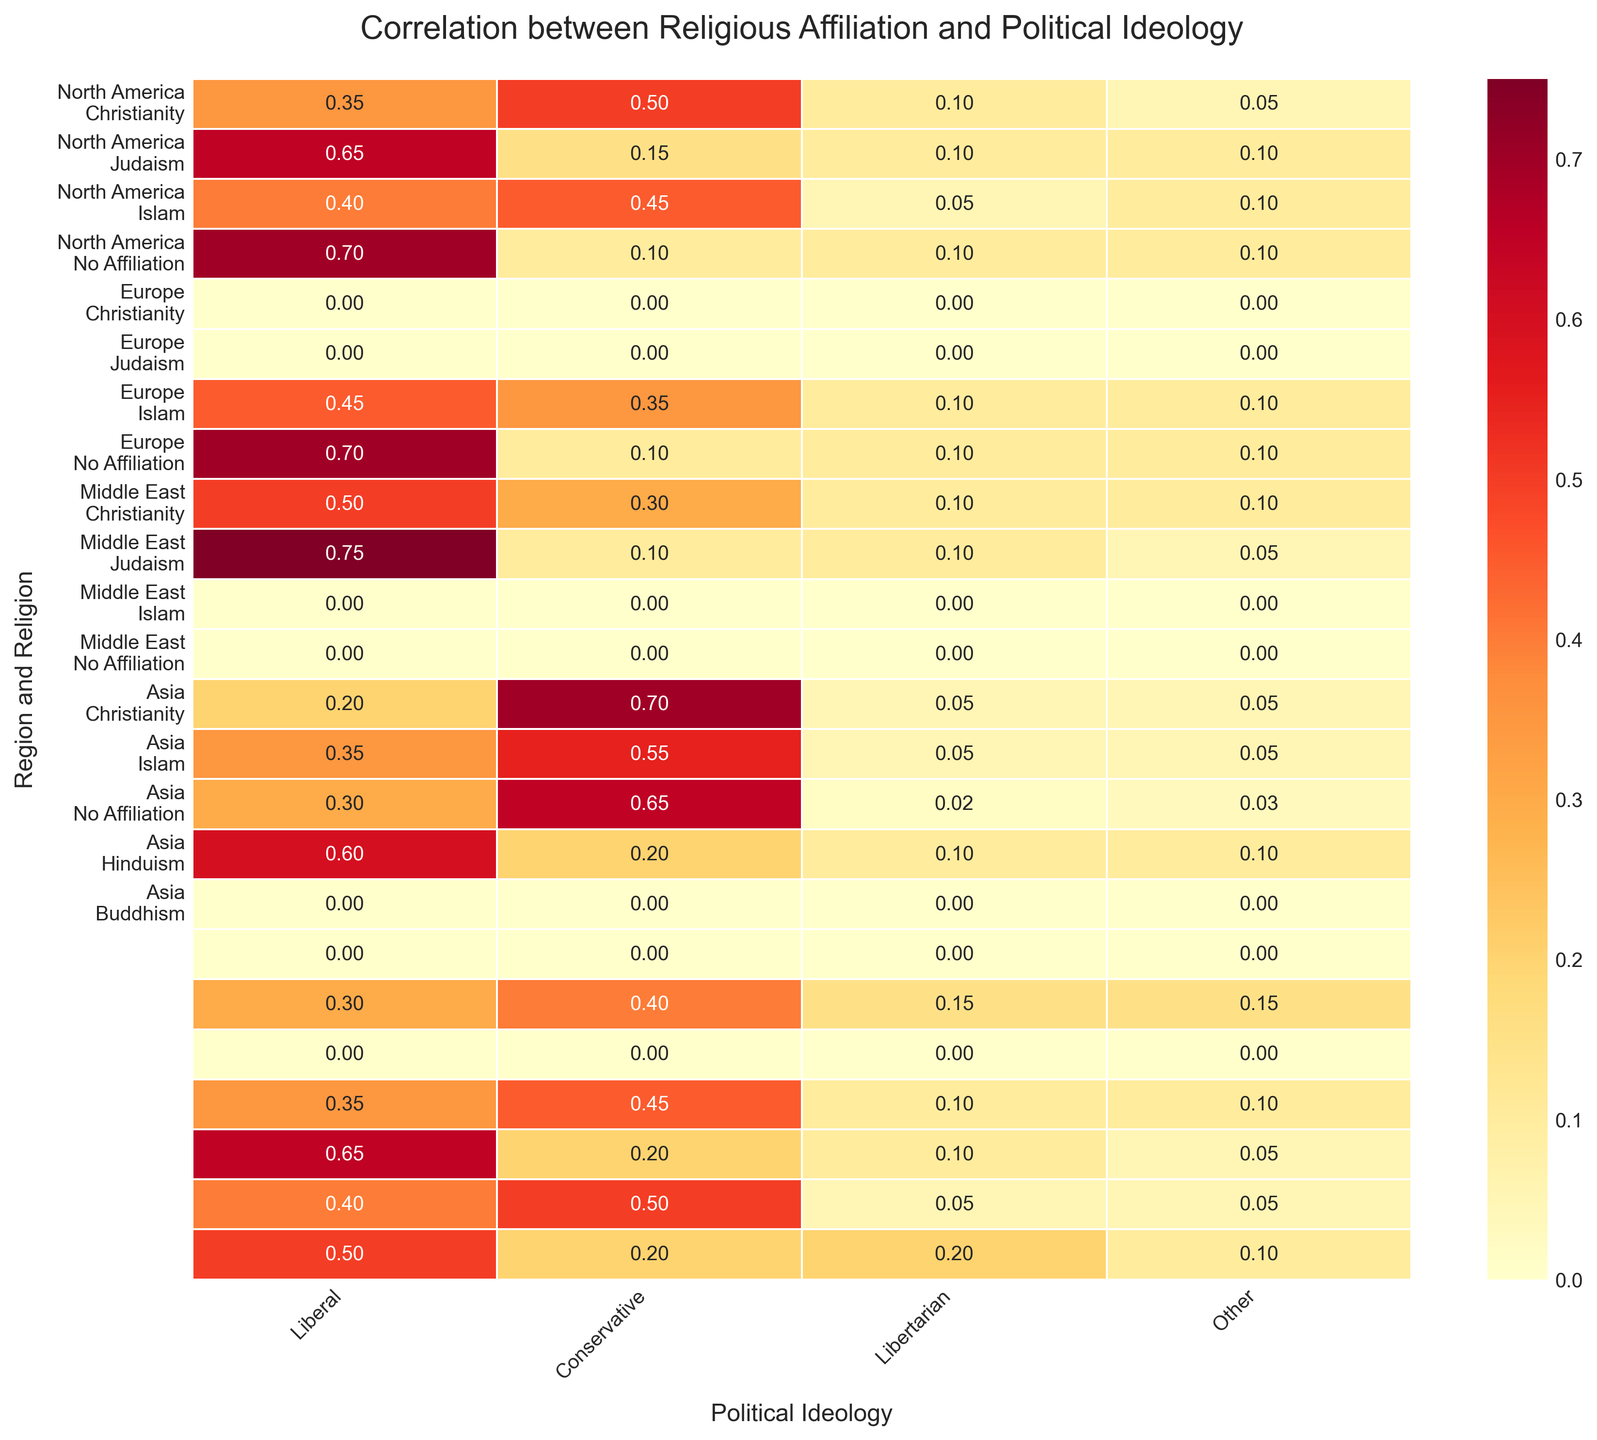Which region and religion combination shows the highest Liberal affiliation? To determine the region and religion combination with the highest Liberal affiliation, look at the annot values under the 'Liberal' column. The highest value is 0.75, which corresponds to Europe and No Affiliation.
Answer: Europe and No Affiliation What is the combined percentage of Conservative affiliation in North America for Christianity, Judaism, and Islam? Add the Conservative values for Christianity, Judaism, and Islam in North America. They are 0.5, 0.15, and 0.45 respectively. Summing these up: 0.5 + 0.15 + 0.45 = 1.1 or 110%.
Answer: 110% Which religious affiliation in Asia has the highest Libertarian percentage? To find this, look at the Libertarian column for all religions in Asia. The highest value is 0.2, which is associated with Buddhism.
Answer: Buddhism Among the regions in the dataset, which combination has the lowest Conservative affiliation? Identify the lowest value in the 'Conservative' column across all region and religion combinations. The lowest value is 0.1, associated with North America No Affiliation and Europe No Affiliation.
Answer: North America No Affiliation and Europe No Affiliation Which region and religion combination has a Liberal affiliation higher than 0.6 but less than 0.7? Look for Liberal values that fall between 0.6 and 0.7 in the figure. The relevant value is 0.65 for North America Judaism.
Answer: North America Judaism How does the Libertarian affiliation of Christianity in North America compare to the same religion in Asia? The Libertarian values for Christianity in North America and Asia are 0.1 and 0.15, respectively. Comparing these values shows that Asia has a higher Libertarian affiliation.
Answer: Asia is higher What is the average Liberal affiliation for Europe? Calculate the average of Liberal values for all religions in Europe. The values are 0.45, 0.7, 0.5, and 0.75. The sum is 0.45 + 0.7 + 0.5 + 0.75 = 2.4. The average is 2.4 / 4 = 0.6.
Answer: 0.6 What is the total percentage of Other affiliations in the Middle East for all religions combined? Sum the Other values for Christianity, Judaism, Islam, and No Affiliation in the Middle East. The values are 0.05, 0.05, 0.03, and 0.1 respectively. The total is 0.05 + 0.05 + 0.03 + 0.1 = 0.23 or 23%.
Answer: 23% 